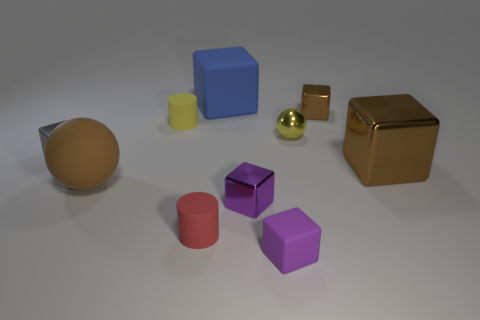Subtract all blue balls. How many brown cubes are left? 2 Subtract all metallic cubes. How many cubes are left? 2 Subtract all purple blocks. How many blocks are left? 4 Subtract 2 blocks. How many blocks are left? 4 Subtract all blocks. How many objects are left? 4 Subtract all purple things. Subtract all tiny metallic spheres. How many objects are left? 7 Add 7 tiny gray objects. How many tiny gray objects are left? 8 Add 1 big yellow shiny cylinders. How many big yellow shiny cylinders exist? 1 Subtract 0 red blocks. How many objects are left? 10 Subtract all blue cylinders. Subtract all purple spheres. How many cylinders are left? 2 